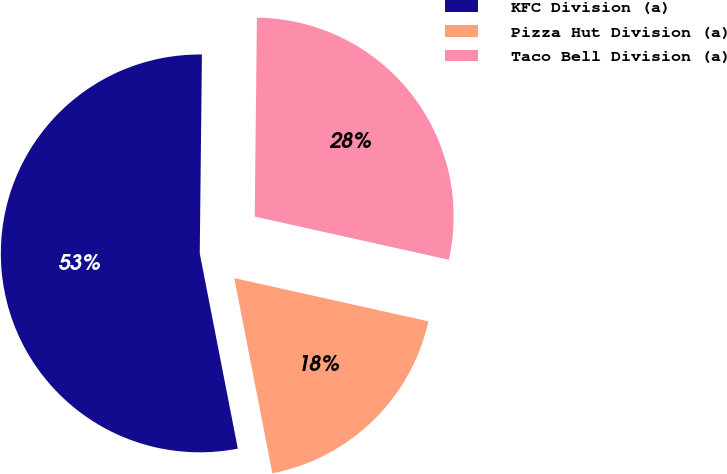Convert chart to OTSL. <chart><loc_0><loc_0><loc_500><loc_500><pie_chart><fcel>KFC Division (a)<fcel>Pizza Hut Division (a)<fcel>Taco Bell Division (a)<nl><fcel>53.24%<fcel>18.45%<fcel>28.31%<nl></chart> 